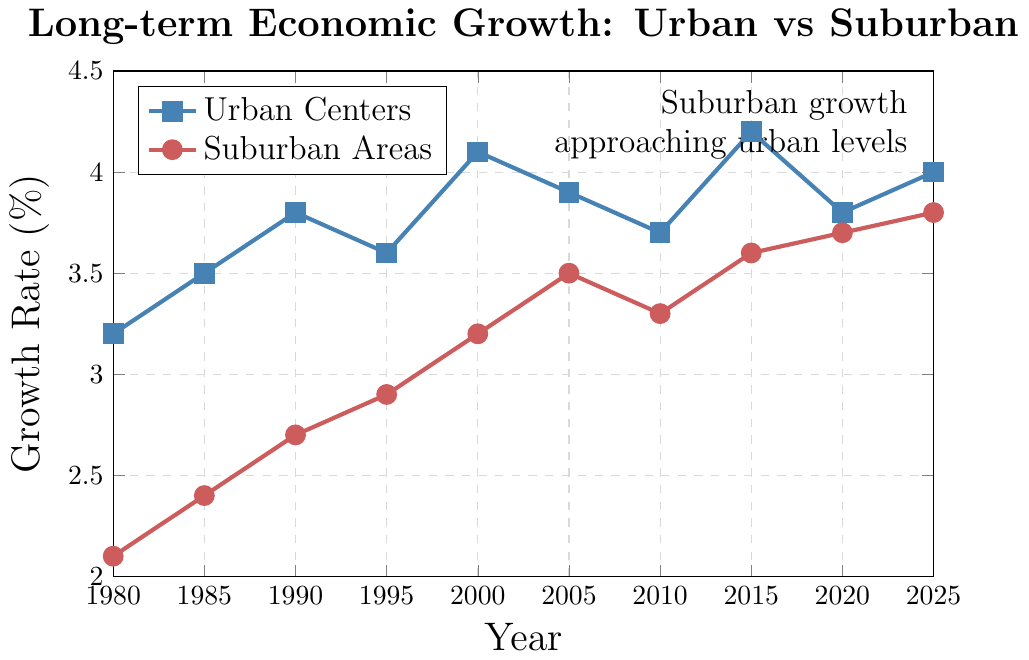How did the growth rates of urban centers and suburban areas compare in the year 2000? In the year 2000, the figure shows the growth rate for urban centers is at 4.1% and for suburban areas, it is at 3.2%. By directly comparing these values, we see that urban centers had a higher growth rate compared to suburban areas.
Answer: Urban centers: 4.1%, Suburban areas: 3.2% What is the overall trend in the growth rates for suburban areas from 1980 to 2025? Observing the suburban areas' growth rate on the figure from 1980 to 2025, we see a consistent increasing trend, starting from 2.1% in 1980 and rising to 3.8% by 2025. The rate increases gradually over this period without any significant declines.
Answer: Increasing trend Which year shows the smallest difference between the growth rates of urban centers and suburban areas? To find the smallest difference, calculate the differences for each year: 1980: 1.1, 1985: 1.1, 1990: 1.1, 1995: 0.7, 2000: 0.9, 2005: 0.4, 2010: 0.4, 2015: 0.6, 2020: 0.1, 2025: 0.2. The smallest difference is in 2020, where it is 0.1.
Answer: 2020 At what point in time do suburban areas’ growth rates start approaching those of urban centers? From the figure, we observe that the suburban areas' growth rates start to closely approach urban centers' growth rates around the year 2005. Before that, the difference is more significant, but post-2005, suburban areas begin to catch up more noticeably.
Answer: Around 2005 What is the mean growth rate for suburban areas over the period provided? Adding the growth rates for suburban areas across all years: 2.1 + 2.4 + 2.7 + 2.9 + 3.2 + 3.5 + 3.3 + 3.6 + 3.7 + 3.8 = 31.2. Dividing this by the number of years (10) gives the mean growth rate.
Answer: 3.12% In which year did urban centers experience the highest growth rate, and what was it? From the figure, the highest growth rate for urban centers occurred in the year 2015, where the growth rate reached 4.2%.
Answer: 2015, 4.2% Compare the color used for the lines representing urban centers and suburban areas. The line representing urban centers is colored blue, whereas the line for suburban areas is red. These colors help distinguish the two areas visually on the plot.
Answer: Urban centers: blue, Suburban areas: red 